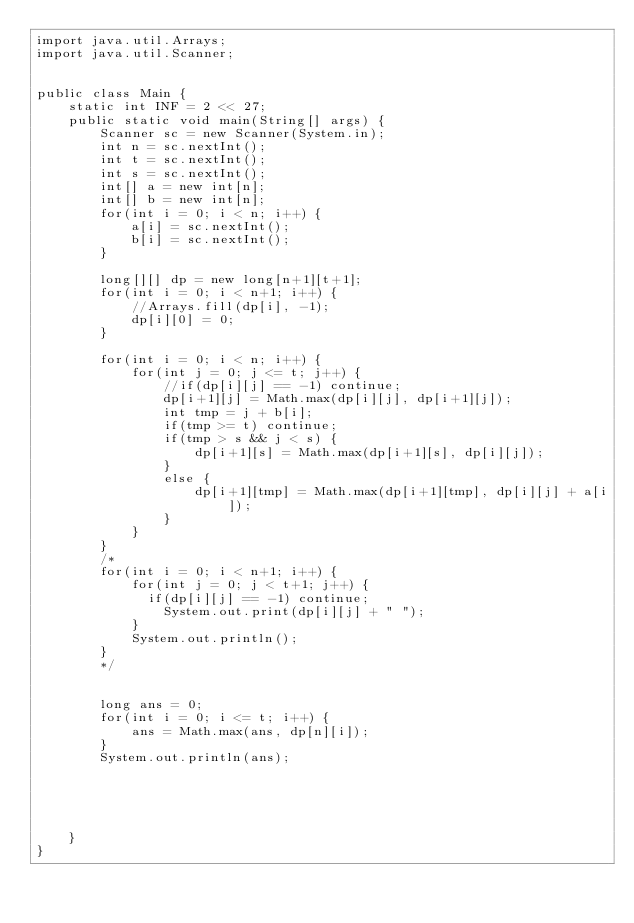<code> <loc_0><loc_0><loc_500><loc_500><_Java_>import java.util.Arrays;
import java.util.Scanner;
   
   
public class Main {
    static int INF = 2 << 27;
    public static void main(String[] args) {
        Scanner sc = new Scanner(System.in);
        int n = sc.nextInt();
        int t = sc.nextInt();
        int s = sc.nextInt();
        int[] a = new int[n];
        int[] b = new int[n];
        for(int i = 0; i < n; i++) {
            a[i] = sc.nextInt();
            b[i] = sc.nextInt();
        }
         
        long[][] dp = new long[n+1][t+1];
        for(int i = 0; i < n+1; i++) {
            //Arrays.fill(dp[i], -1);
            dp[i][0] = 0;
        }
         
        for(int i = 0; i < n; i++) {
            for(int j = 0; j <= t; j++) {
                //if(dp[i][j] == -1) continue;
                dp[i+1][j] = Math.max(dp[i][j], dp[i+1][j]);
                int tmp = j + b[i];
                if(tmp >= t) continue;
                if(tmp > s && j < s) {
                    dp[i+1][s] = Math.max(dp[i+1][s], dp[i][j]);
                }
                else {
                    dp[i+1][tmp] = Math.max(dp[i+1][tmp], dp[i][j] + a[i]);
                }
            }
        }
        /*
        for(int i = 0; i < n+1; i++) {
            for(int j = 0; j < t+1; j++) {
            	if(dp[i][j] == -1) continue;
                System.out.print(dp[i][j] + " ");
            }
            System.out.println();
        }
        */
        
         
        long ans = 0;
        for(int i = 0; i <= t; i++) {
            ans = Math.max(ans, dp[n][i]);
        }
        System.out.println(ans);
         
         
         
         
         
    }
}</code> 